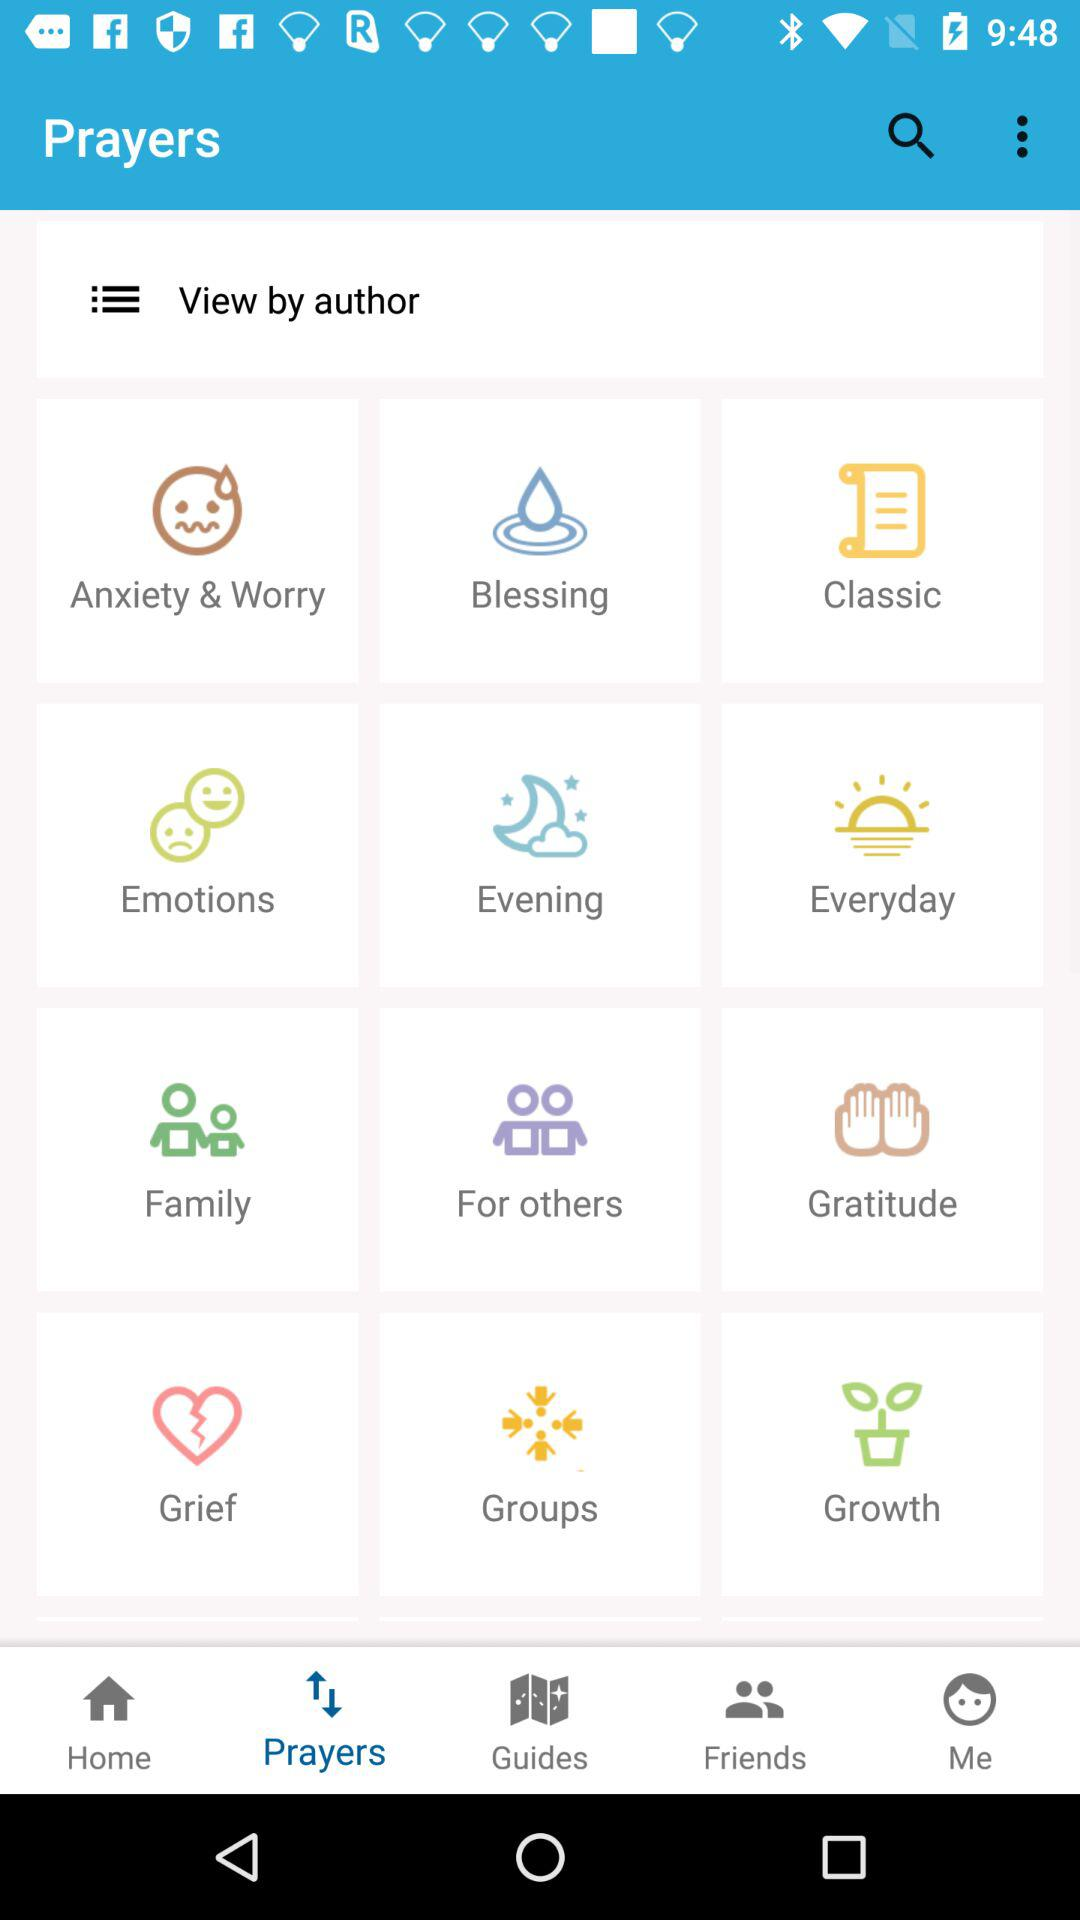What are the names of the prayers that are shown in "View by Author"? The names of the prayers that are shown in "View by Author" are "Anxiety & Worry", "Blessing", "Classic", "Emotions", "Emotions", "Evening", "Everyday", "Family", "For others", "Gratitude", "Grief", "Groups" and "Growth". 